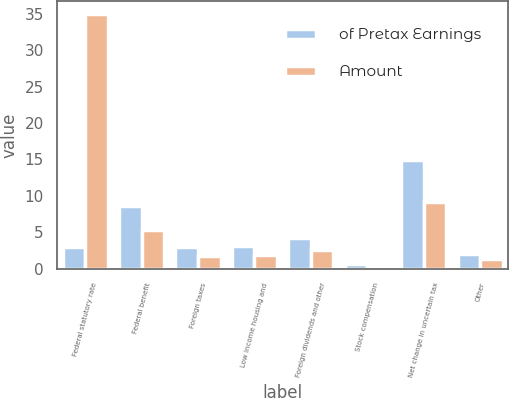Convert chart. <chart><loc_0><loc_0><loc_500><loc_500><stacked_bar_chart><ecel><fcel>Federal statutory rate<fcel>Federal benefit<fcel>Foreign taxes<fcel>Low income housing and<fcel>Foreign dividends and other<fcel>Stock compensation<fcel>Net change in uncertain tax<fcel>Other<nl><fcel>of Pretax Earnings<fcel>3<fcel>8.6<fcel>3<fcel>3.1<fcel>4.2<fcel>0.6<fcel>14.9<fcel>2.1<nl><fcel>Amount<fcel>35<fcel>5.3<fcel>1.8<fcel>1.9<fcel>2.6<fcel>0.4<fcel>9.1<fcel>1.3<nl></chart> 